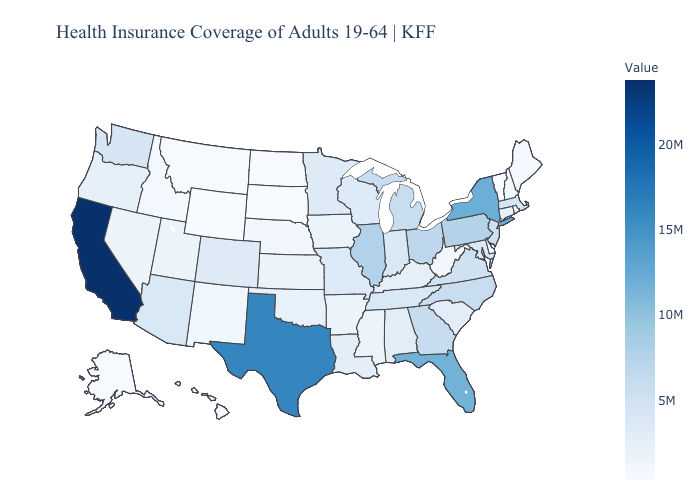Which states have the highest value in the USA?
Keep it brief. California. Does Alaska have the lowest value in the USA?
Write a very short answer. No. Does Wyoming have the lowest value in the USA?
Quick response, please. Yes. Among the states that border Tennessee , does Alabama have the lowest value?
Quick response, please. No. Which states have the highest value in the USA?
Short answer required. California. 